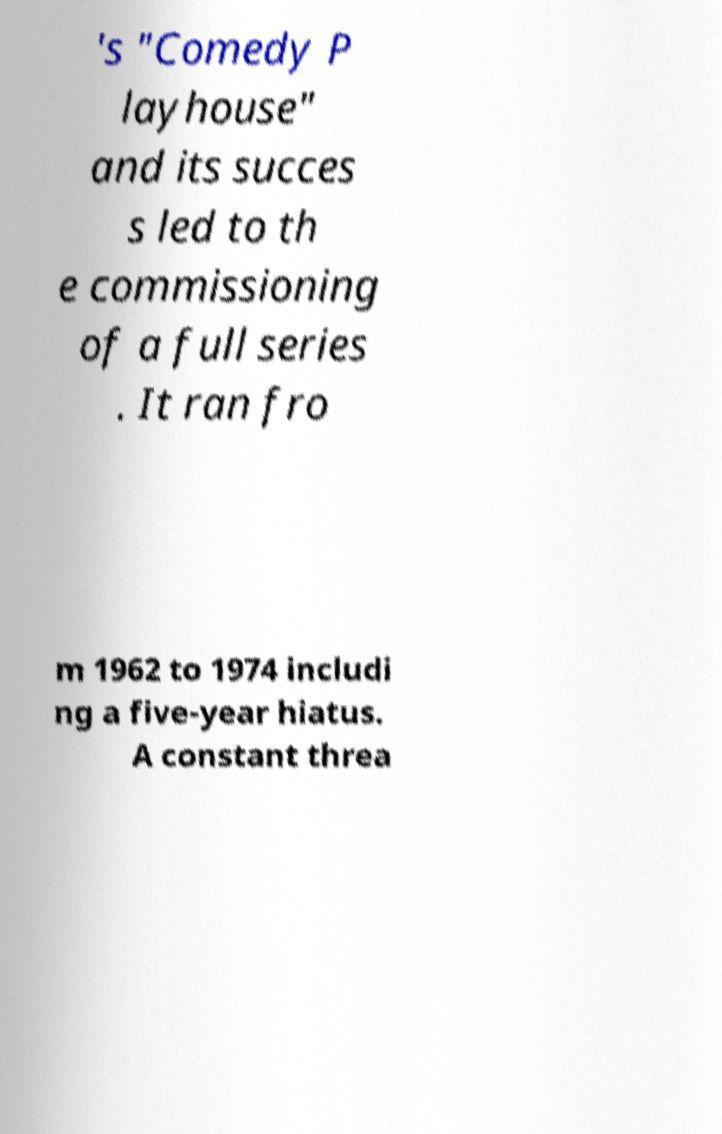Can you read and provide the text displayed in the image?This photo seems to have some interesting text. Can you extract and type it out for me? 's "Comedy P layhouse" and its succes s led to th e commissioning of a full series . It ran fro m 1962 to 1974 includi ng a five-year hiatus. A constant threa 